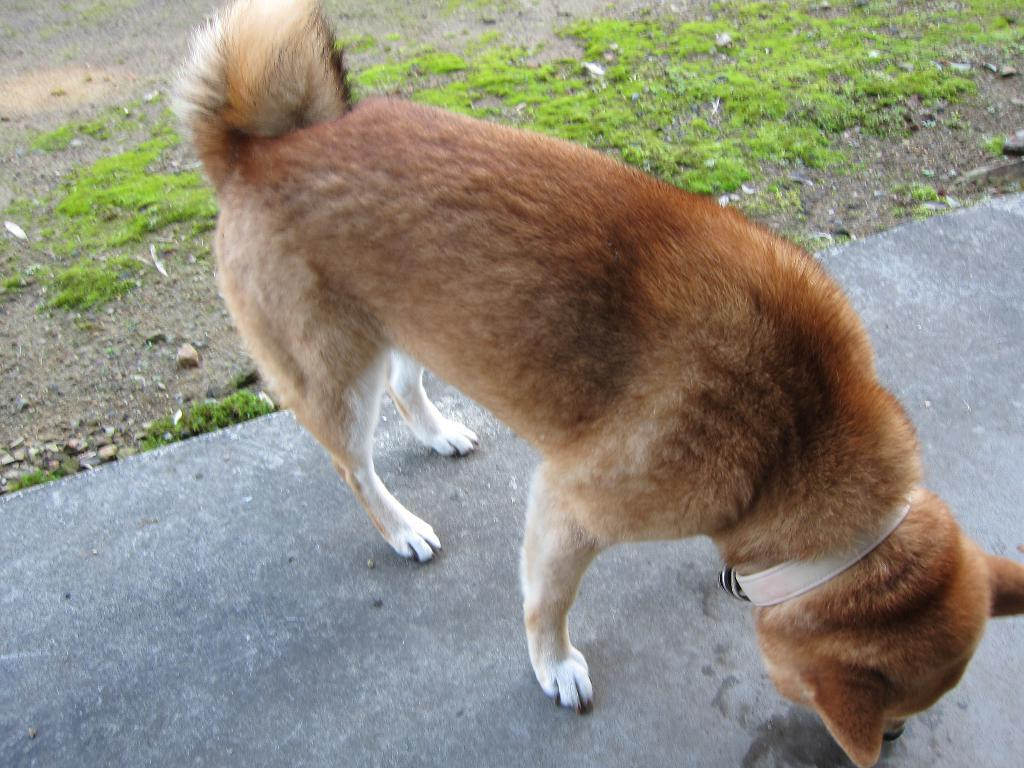What type of animal is present in the image? There is a dog in the image. What is the dog wearing? The dog is wearing a belt. Where is the dog located in the image? The dog is on the ground. What can be seen in the background of the image? There is grass in the background of the image. What type of mine can be seen in the image? There is no mine present in the image; it features a dog wearing a belt and standing on the ground with grass in the background. 